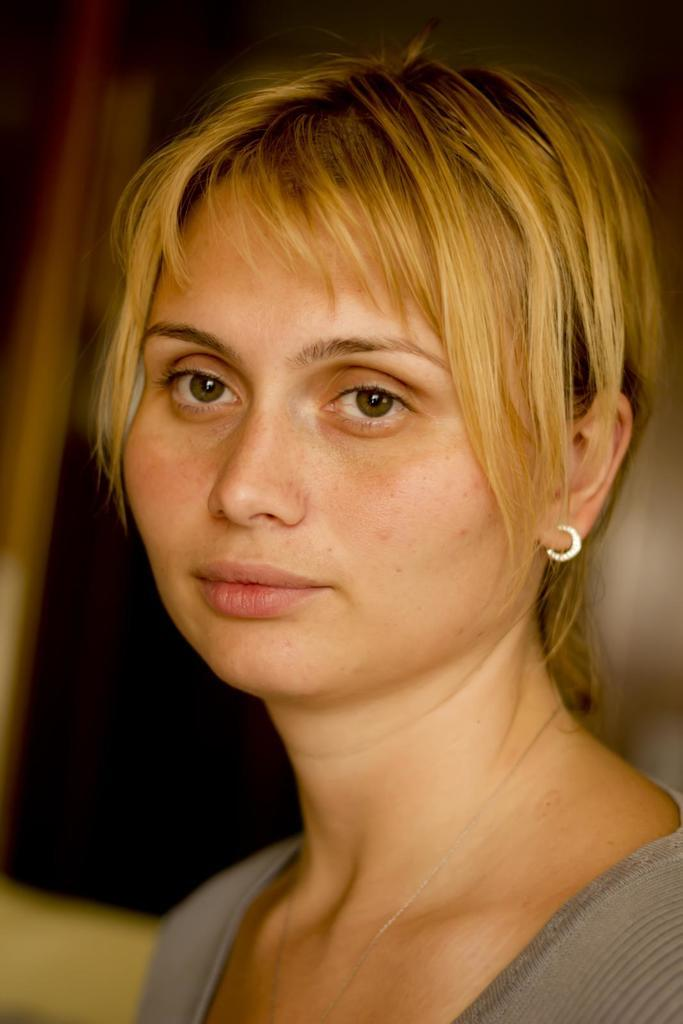Who is the main subject in the image? There is a woman in the image. Can you describe the background of the image? The background of the image is blurry. What types of toys can be seen in the image? There are no toys present in the image; it features a woman with a blurry background. Is the woman's aunt in the image? The provided facts do not mention the woman's aunt, so it cannot be determined from the image. 